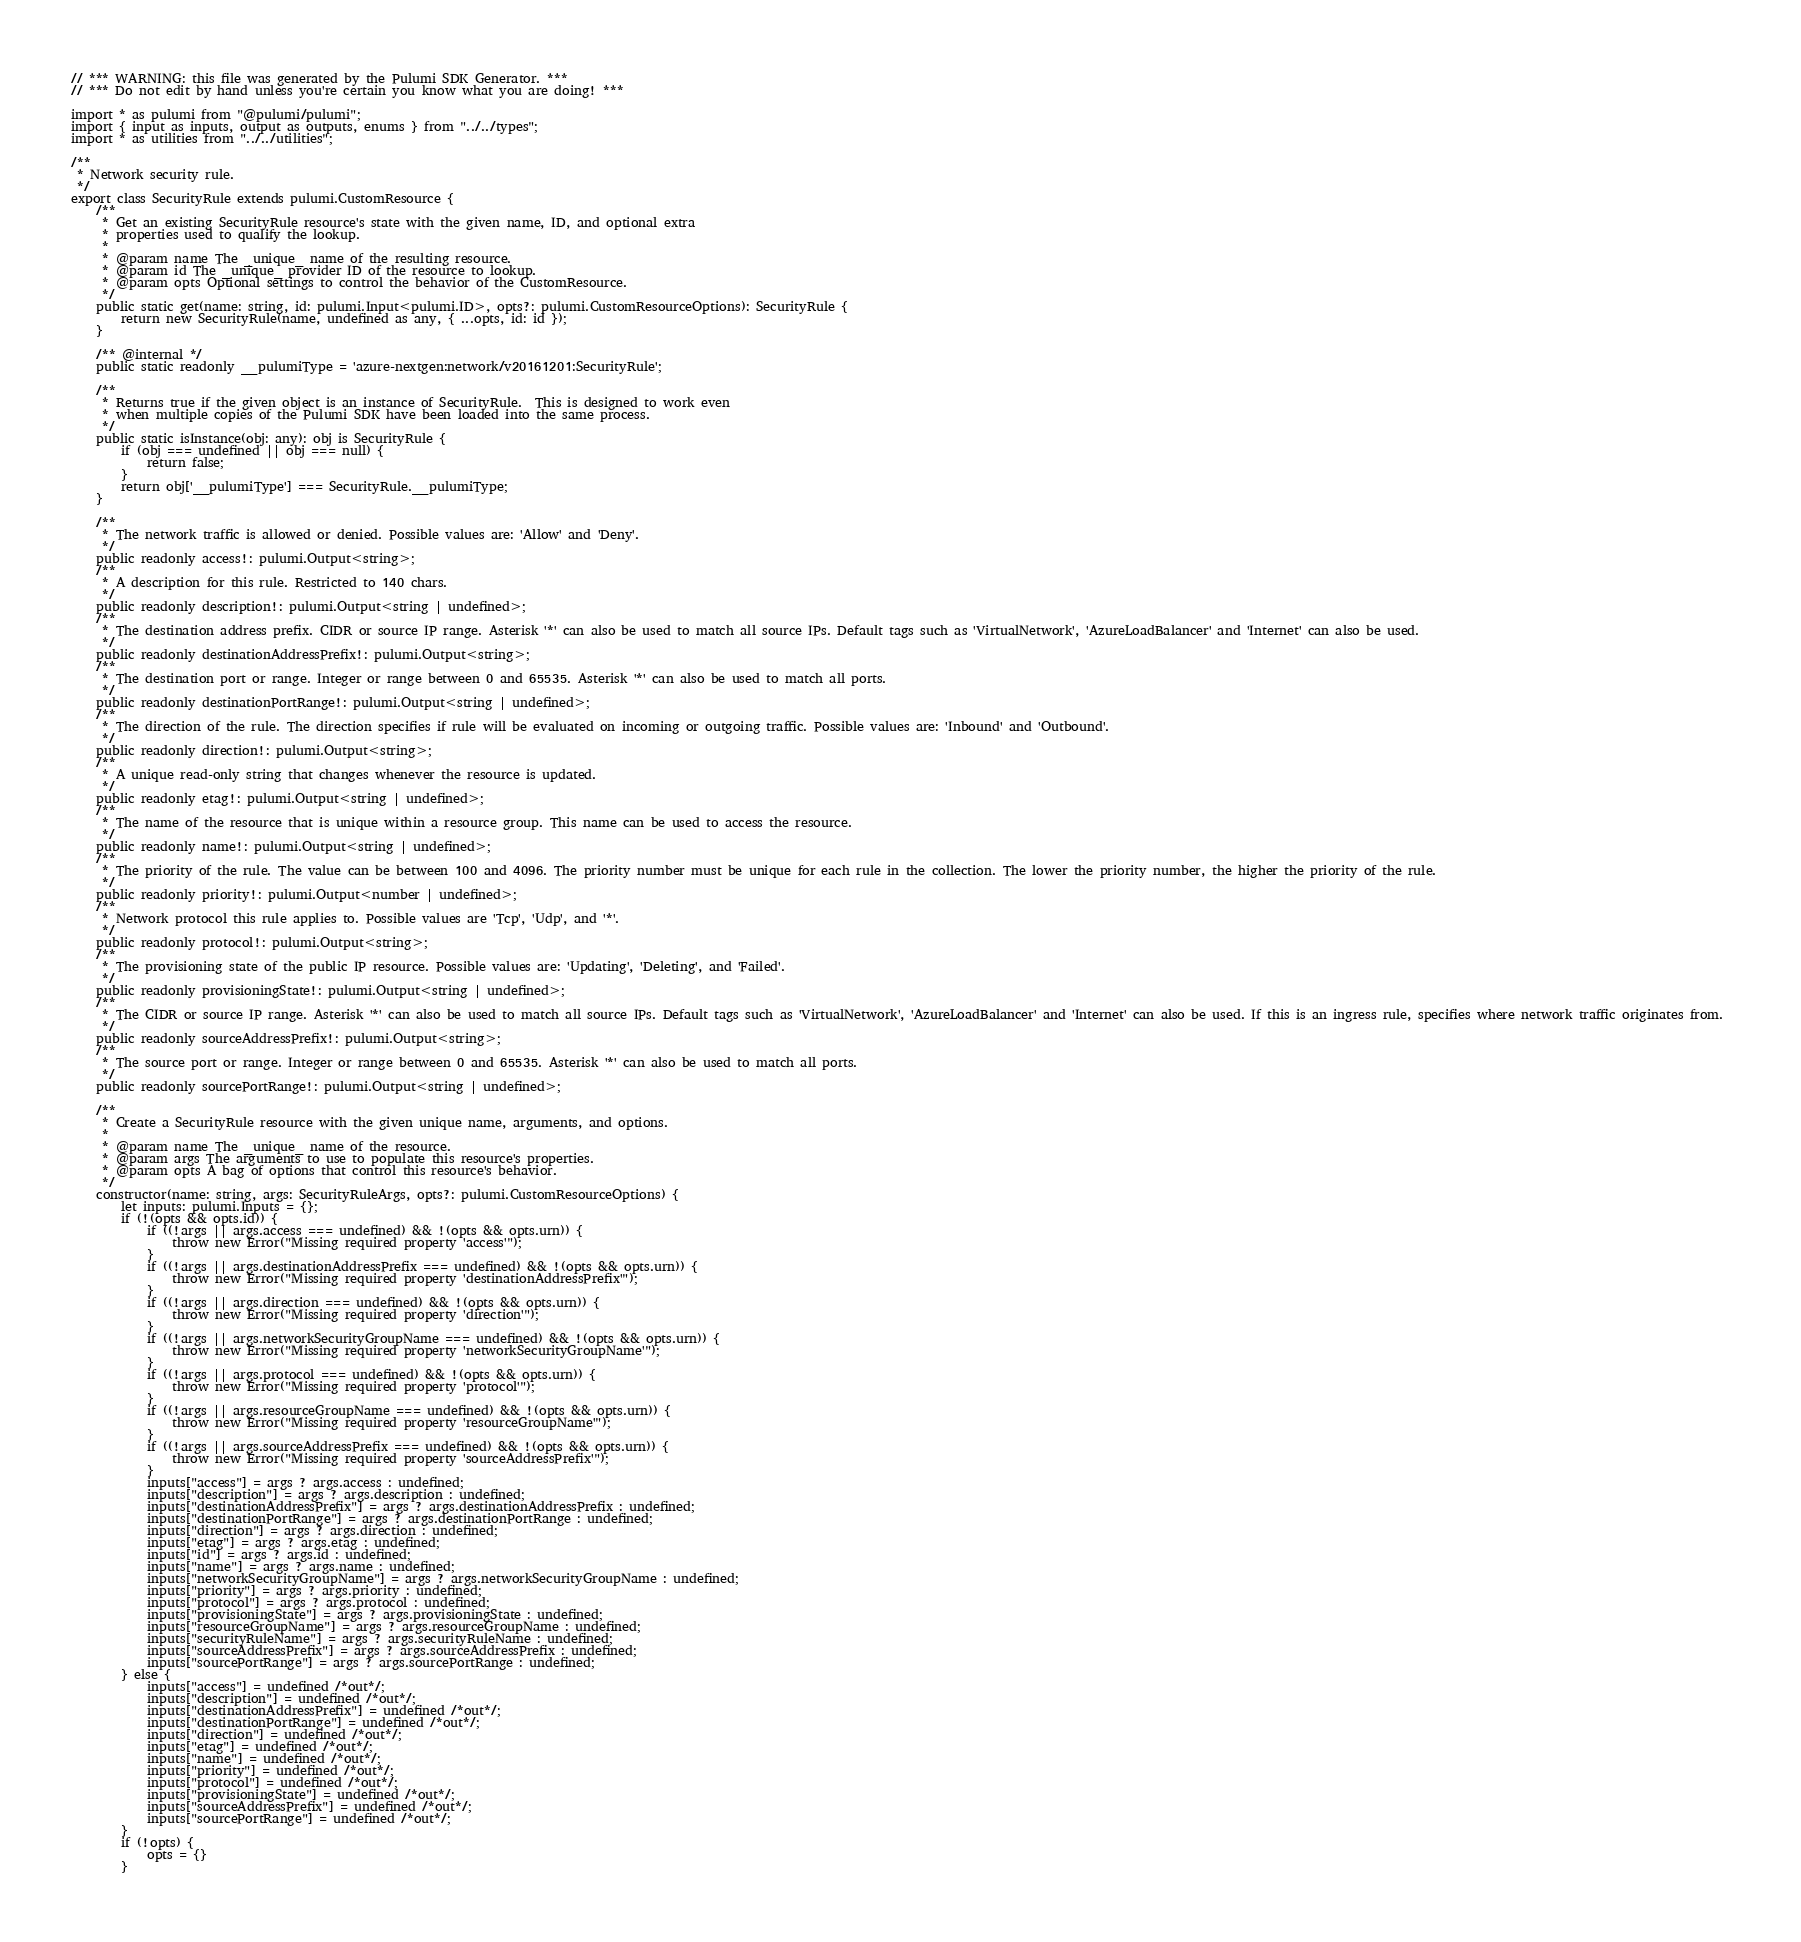<code> <loc_0><loc_0><loc_500><loc_500><_TypeScript_>// *** WARNING: this file was generated by the Pulumi SDK Generator. ***
// *** Do not edit by hand unless you're certain you know what you are doing! ***

import * as pulumi from "@pulumi/pulumi";
import { input as inputs, output as outputs, enums } from "../../types";
import * as utilities from "../../utilities";

/**
 * Network security rule.
 */
export class SecurityRule extends pulumi.CustomResource {
    /**
     * Get an existing SecurityRule resource's state with the given name, ID, and optional extra
     * properties used to qualify the lookup.
     *
     * @param name The _unique_ name of the resulting resource.
     * @param id The _unique_ provider ID of the resource to lookup.
     * @param opts Optional settings to control the behavior of the CustomResource.
     */
    public static get(name: string, id: pulumi.Input<pulumi.ID>, opts?: pulumi.CustomResourceOptions): SecurityRule {
        return new SecurityRule(name, undefined as any, { ...opts, id: id });
    }

    /** @internal */
    public static readonly __pulumiType = 'azure-nextgen:network/v20161201:SecurityRule';

    /**
     * Returns true if the given object is an instance of SecurityRule.  This is designed to work even
     * when multiple copies of the Pulumi SDK have been loaded into the same process.
     */
    public static isInstance(obj: any): obj is SecurityRule {
        if (obj === undefined || obj === null) {
            return false;
        }
        return obj['__pulumiType'] === SecurityRule.__pulumiType;
    }

    /**
     * The network traffic is allowed or denied. Possible values are: 'Allow' and 'Deny'.
     */
    public readonly access!: pulumi.Output<string>;
    /**
     * A description for this rule. Restricted to 140 chars.
     */
    public readonly description!: pulumi.Output<string | undefined>;
    /**
     * The destination address prefix. CIDR or source IP range. Asterisk '*' can also be used to match all source IPs. Default tags such as 'VirtualNetwork', 'AzureLoadBalancer' and 'Internet' can also be used.
     */
    public readonly destinationAddressPrefix!: pulumi.Output<string>;
    /**
     * The destination port or range. Integer or range between 0 and 65535. Asterisk '*' can also be used to match all ports.
     */
    public readonly destinationPortRange!: pulumi.Output<string | undefined>;
    /**
     * The direction of the rule. The direction specifies if rule will be evaluated on incoming or outgoing traffic. Possible values are: 'Inbound' and 'Outbound'.
     */
    public readonly direction!: pulumi.Output<string>;
    /**
     * A unique read-only string that changes whenever the resource is updated.
     */
    public readonly etag!: pulumi.Output<string | undefined>;
    /**
     * The name of the resource that is unique within a resource group. This name can be used to access the resource.
     */
    public readonly name!: pulumi.Output<string | undefined>;
    /**
     * The priority of the rule. The value can be between 100 and 4096. The priority number must be unique for each rule in the collection. The lower the priority number, the higher the priority of the rule.
     */
    public readonly priority!: pulumi.Output<number | undefined>;
    /**
     * Network protocol this rule applies to. Possible values are 'Tcp', 'Udp', and '*'.
     */
    public readonly protocol!: pulumi.Output<string>;
    /**
     * The provisioning state of the public IP resource. Possible values are: 'Updating', 'Deleting', and 'Failed'.
     */
    public readonly provisioningState!: pulumi.Output<string | undefined>;
    /**
     * The CIDR or source IP range. Asterisk '*' can also be used to match all source IPs. Default tags such as 'VirtualNetwork', 'AzureLoadBalancer' and 'Internet' can also be used. If this is an ingress rule, specifies where network traffic originates from. 
     */
    public readonly sourceAddressPrefix!: pulumi.Output<string>;
    /**
     * The source port or range. Integer or range between 0 and 65535. Asterisk '*' can also be used to match all ports.
     */
    public readonly sourcePortRange!: pulumi.Output<string | undefined>;

    /**
     * Create a SecurityRule resource with the given unique name, arguments, and options.
     *
     * @param name The _unique_ name of the resource.
     * @param args The arguments to use to populate this resource's properties.
     * @param opts A bag of options that control this resource's behavior.
     */
    constructor(name: string, args: SecurityRuleArgs, opts?: pulumi.CustomResourceOptions) {
        let inputs: pulumi.Inputs = {};
        if (!(opts && opts.id)) {
            if ((!args || args.access === undefined) && !(opts && opts.urn)) {
                throw new Error("Missing required property 'access'");
            }
            if ((!args || args.destinationAddressPrefix === undefined) && !(opts && opts.urn)) {
                throw new Error("Missing required property 'destinationAddressPrefix'");
            }
            if ((!args || args.direction === undefined) && !(opts && opts.urn)) {
                throw new Error("Missing required property 'direction'");
            }
            if ((!args || args.networkSecurityGroupName === undefined) && !(opts && opts.urn)) {
                throw new Error("Missing required property 'networkSecurityGroupName'");
            }
            if ((!args || args.protocol === undefined) && !(opts && opts.urn)) {
                throw new Error("Missing required property 'protocol'");
            }
            if ((!args || args.resourceGroupName === undefined) && !(opts && opts.urn)) {
                throw new Error("Missing required property 'resourceGroupName'");
            }
            if ((!args || args.sourceAddressPrefix === undefined) && !(opts && opts.urn)) {
                throw new Error("Missing required property 'sourceAddressPrefix'");
            }
            inputs["access"] = args ? args.access : undefined;
            inputs["description"] = args ? args.description : undefined;
            inputs["destinationAddressPrefix"] = args ? args.destinationAddressPrefix : undefined;
            inputs["destinationPortRange"] = args ? args.destinationPortRange : undefined;
            inputs["direction"] = args ? args.direction : undefined;
            inputs["etag"] = args ? args.etag : undefined;
            inputs["id"] = args ? args.id : undefined;
            inputs["name"] = args ? args.name : undefined;
            inputs["networkSecurityGroupName"] = args ? args.networkSecurityGroupName : undefined;
            inputs["priority"] = args ? args.priority : undefined;
            inputs["protocol"] = args ? args.protocol : undefined;
            inputs["provisioningState"] = args ? args.provisioningState : undefined;
            inputs["resourceGroupName"] = args ? args.resourceGroupName : undefined;
            inputs["securityRuleName"] = args ? args.securityRuleName : undefined;
            inputs["sourceAddressPrefix"] = args ? args.sourceAddressPrefix : undefined;
            inputs["sourcePortRange"] = args ? args.sourcePortRange : undefined;
        } else {
            inputs["access"] = undefined /*out*/;
            inputs["description"] = undefined /*out*/;
            inputs["destinationAddressPrefix"] = undefined /*out*/;
            inputs["destinationPortRange"] = undefined /*out*/;
            inputs["direction"] = undefined /*out*/;
            inputs["etag"] = undefined /*out*/;
            inputs["name"] = undefined /*out*/;
            inputs["priority"] = undefined /*out*/;
            inputs["protocol"] = undefined /*out*/;
            inputs["provisioningState"] = undefined /*out*/;
            inputs["sourceAddressPrefix"] = undefined /*out*/;
            inputs["sourcePortRange"] = undefined /*out*/;
        }
        if (!opts) {
            opts = {}
        }
</code> 